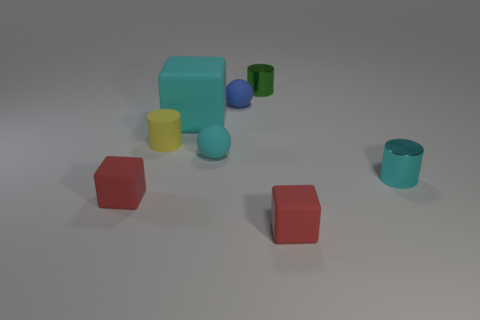Add 1 rubber cylinders. How many objects exist? 9 Subtract all cylinders. How many objects are left? 5 Subtract 0 purple balls. How many objects are left? 8 Subtract all large yellow rubber spheres. Subtract all cyan shiny cylinders. How many objects are left? 7 Add 4 small yellow rubber objects. How many small yellow rubber objects are left? 5 Add 1 cyan blocks. How many cyan blocks exist? 2 